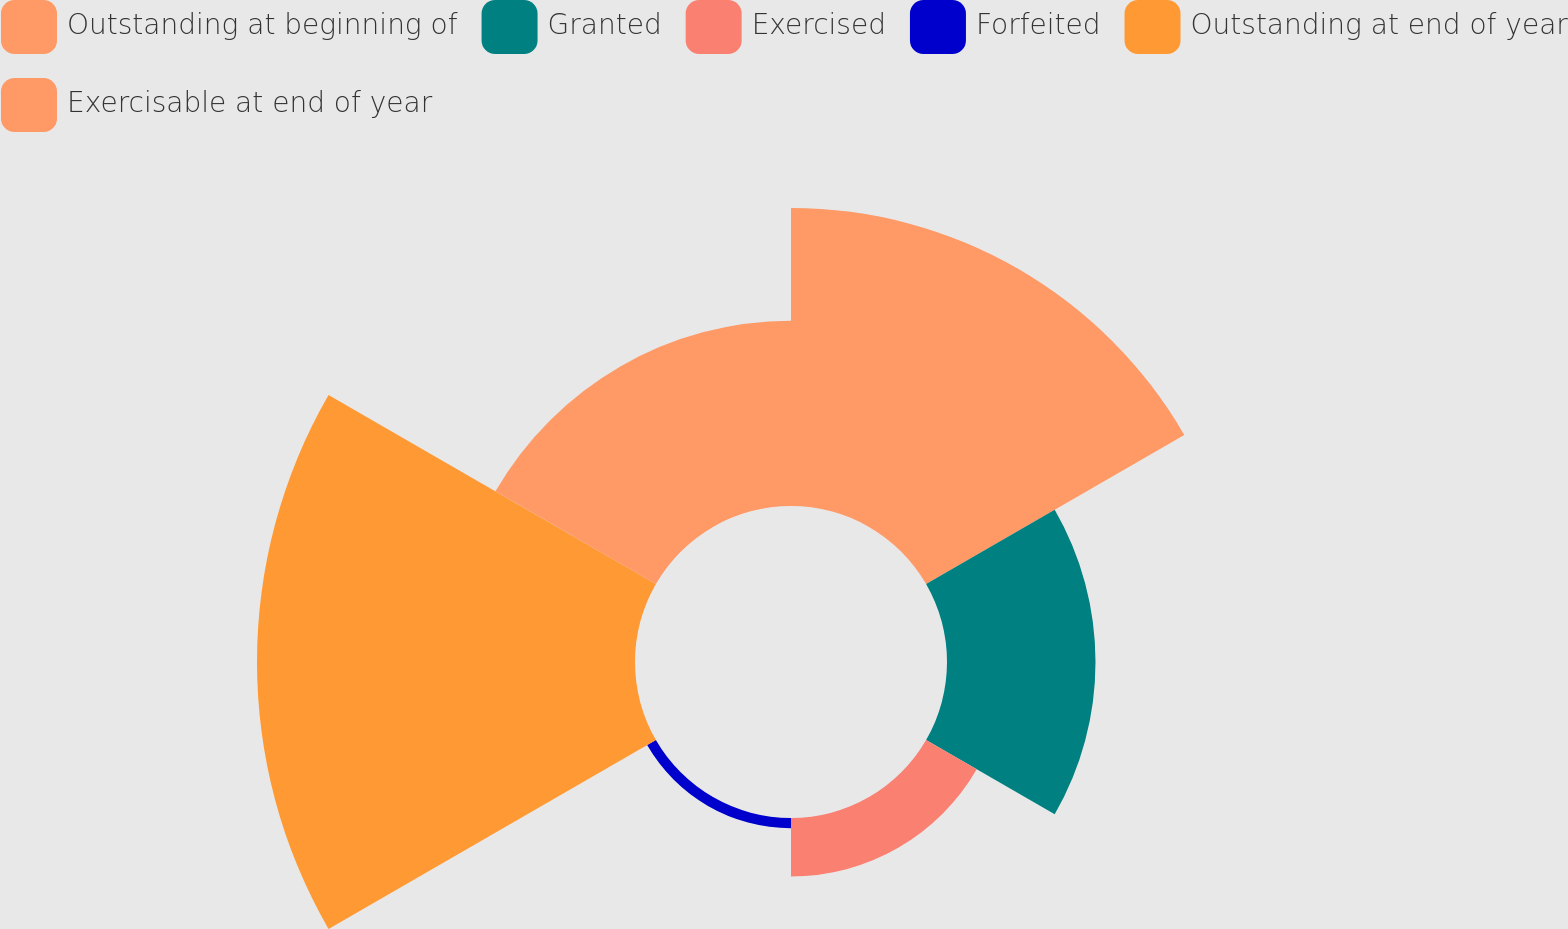Convert chart to OTSL. <chart><loc_0><loc_0><loc_500><loc_500><pie_chart><fcel>Outstanding at beginning of<fcel>Granted<fcel>Exercised<fcel>Forfeited<fcel>Outstanding at end of year<fcel>Exercisable at end of year<nl><fcel>27.64%<fcel>13.77%<fcel>5.42%<fcel>0.94%<fcel>35.05%<fcel>17.18%<nl></chart> 